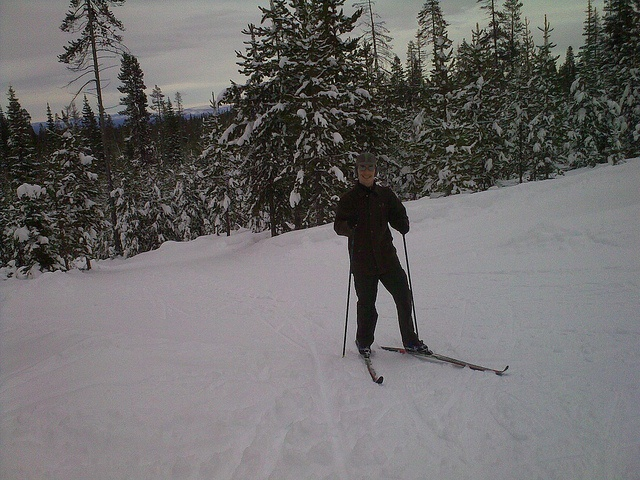Describe the objects in this image and their specific colors. I can see people in gray, black, darkgray, and maroon tones and skis in gray, black, and maroon tones in this image. 